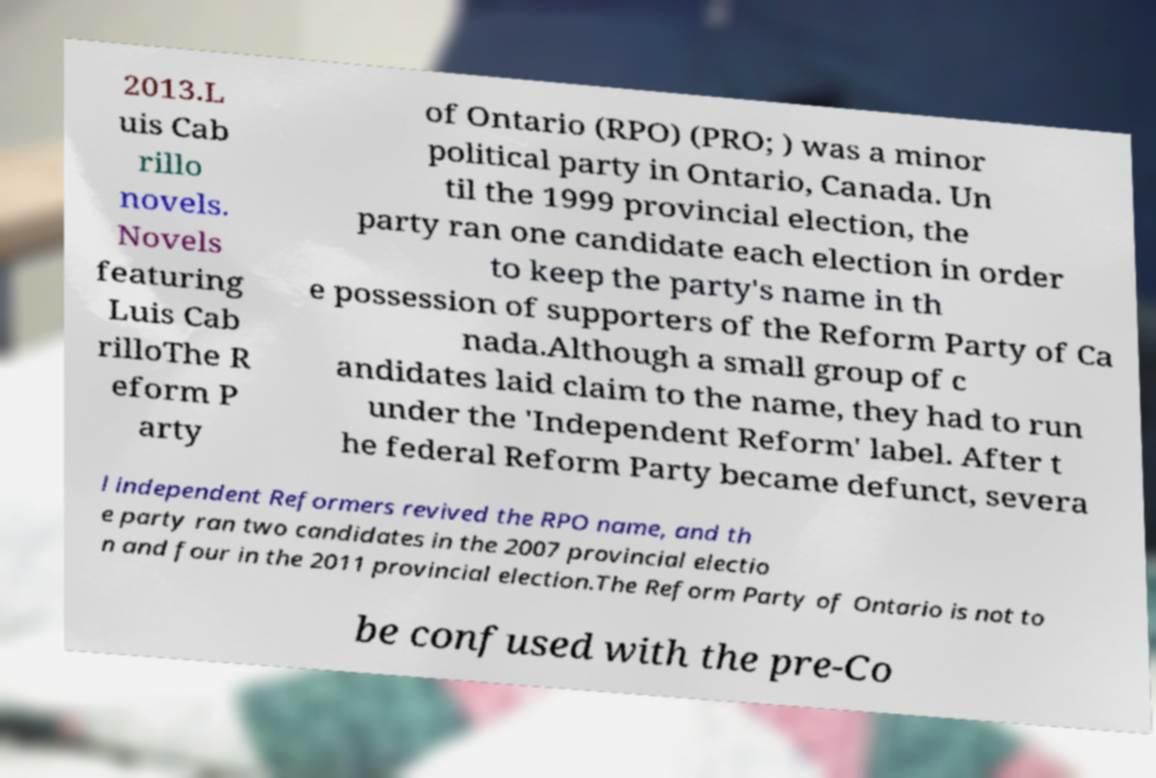I need the written content from this picture converted into text. Can you do that? 2013.L uis Cab rillo novels. Novels featuring Luis Cab rilloThe R eform P arty of Ontario (RPO) (PRO; ) was a minor political party in Ontario, Canada. Un til the 1999 provincial election, the party ran one candidate each election in order to keep the party's name in th e possession of supporters of the Reform Party of Ca nada.Although a small group of c andidates laid claim to the name, they had to run under the 'Independent Reform' label. After t he federal Reform Party became defunct, severa l independent Reformers revived the RPO name, and th e party ran two candidates in the 2007 provincial electio n and four in the 2011 provincial election.The Reform Party of Ontario is not to be confused with the pre-Co 